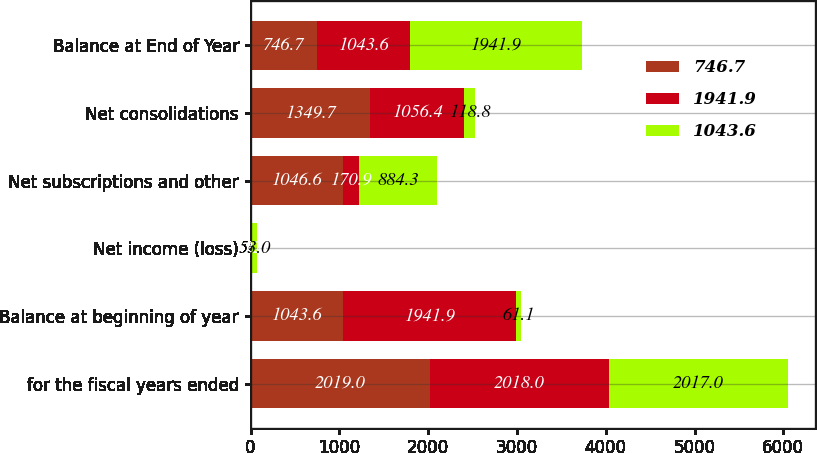<chart> <loc_0><loc_0><loc_500><loc_500><stacked_bar_chart><ecel><fcel>for the fiscal years ended<fcel>Balance at beginning of year<fcel>Net income (loss)<fcel>Net subscriptions and other<fcel>Net consolidations<fcel>Balance at End of Year<nl><fcel>746.7<fcel>2019<fcel>1043.6<fcel>6.2<fcel>1046.6<fcel>1349.7<fcel>746.7<nl><fcel>1941.9<fcel>2018<fcel>1941.9<fcel>12.8<fcel>170.9<fcel>1056.4<fcel>1043.6<nl><fcel>1043.6<fcel>2017<fcel>61.1<fcel>53<fcel>884.3<fcel>118.8<fcel>1941.9<nl></chart> 